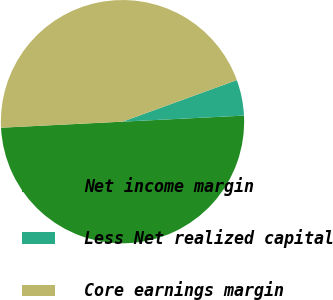<chart> <loc_0><loc_0><loc_500><loc_500><pie_chart><fcel>Net income margin<fcel>Less Net realized capital<fcel>Core earnings margin<nl><fcel>50.0%<fcel>4.76%<fcel>45.24%<nl></chart> 